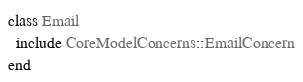Convert code to text. <code><loc_0><loc_0><loc_500><loc_500><_Ruby_>class Email
  include CoreModelConcerns::EmailConcern
end
</code> 